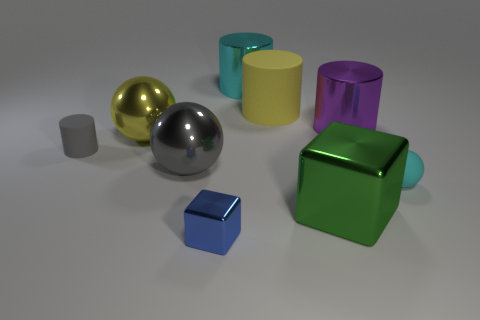Subtract 1 cylinders. How many cylinders are left? 3 Add 1 metal things. How many objects exist? 10 Subtract all cubes. How many objects are left? 7 Subtract all large blue metal cylinders. Subtract all rubber cylinders. How many objects are left? 7 Add 1 tiny matte cylinders. How many tiny matte cylinders are left? 2 Add 9 large purple rubber spheres. How many large purple rubber spheres exist? 9 Subtract 0 red blocks. How many objects are left? 9 